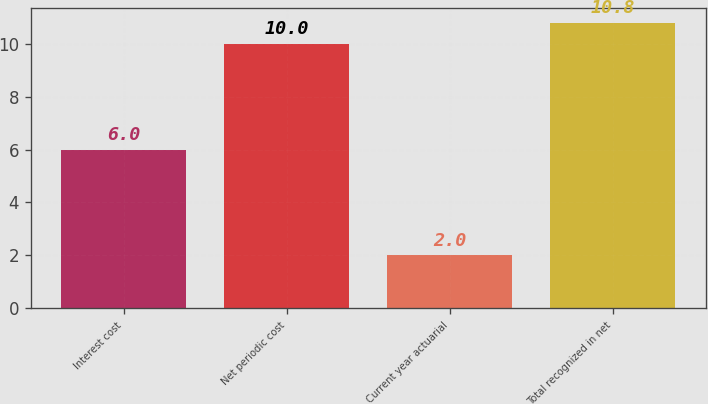Convert chart to OTSL. <chart><loc_0><loc_0><loc_500><loc_500><bar_chart><fcel>Interest cost<fcel>Net periodic cost<fcel>Current year actuarial<fcel>Total recognized in net<nl><fcel>6<fcel>10<fcel>2<fcel>10.8<nl></chart> 